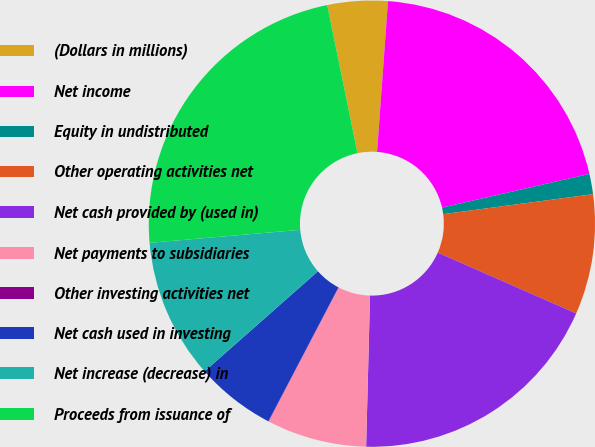<chart> <loc_0><loc_0><loc_500><loc_500><pie_chart><fcel>(Dollars in millions)<fcel>Net income<fcel>Equity in undistributed<fcel>Other operating activities net<fcel>Net cash provided by (used in)<fcel>Net payments to subsidiaries<fcel>Other investing activities net<fcel>Net cash used in investing<fcel>Net increase (decrease) in<fcel>Proceeds from issuance of<nl><fcel>4.36%<fcel>20.27%<fcel>1.47%<fcel>8.7%<fcel>18.82%<fcel>7.25%<fcel>0.02%<fcel>5.81%<fcel>10.14%<fcel>23.16%<nl></chart> 